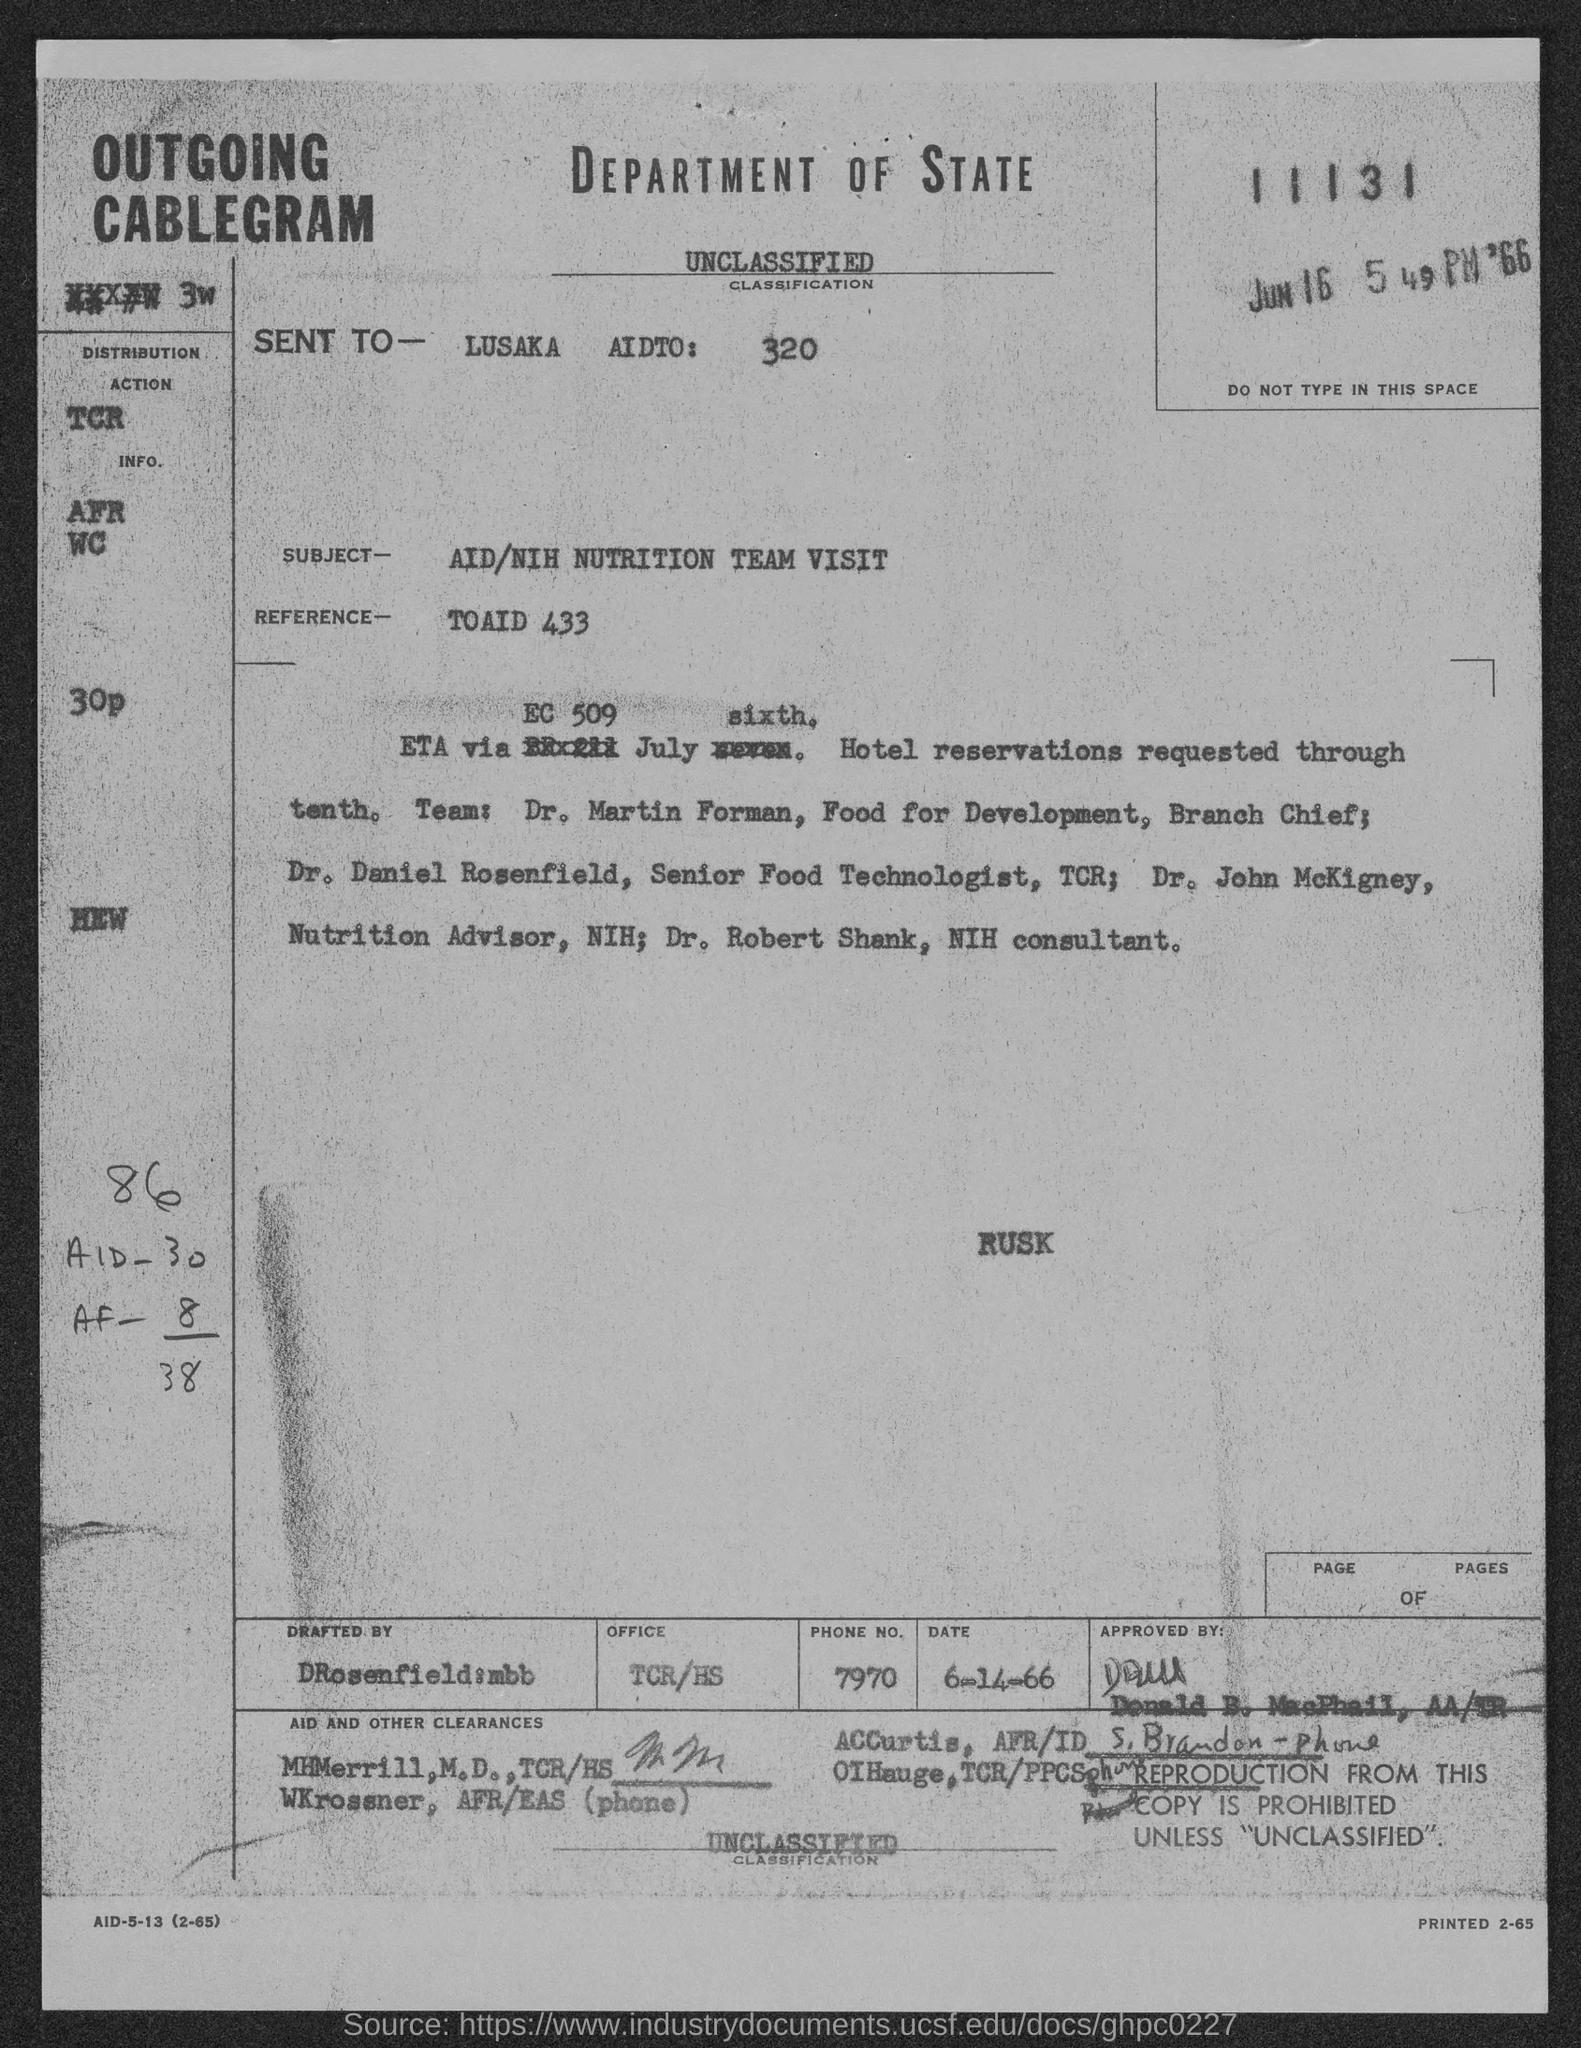Point out several critical features in this image. The classification is currently unclassified. The message is being sent to Lusaka Aid. The reference for TOAID 433 is... The subject of the sentence is "What is the subject? 